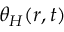Convert formula to latex. <formula><loc_0><loc_0><loc_500><loc_500>\theta _ { H } ( r , t )</formula> 